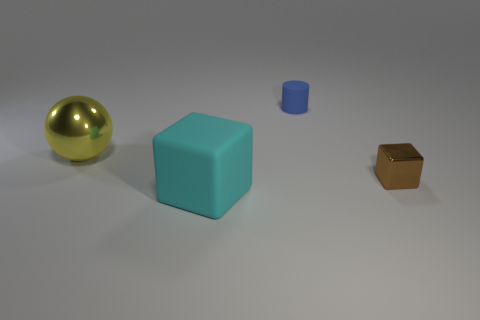Add 3 big rubber objects. How many objects exist? 7 Subtract all blue matte things. Subtract all balls. How many objects are left? 2 Add 1 cyan matte objects. How many cyan matte objects are left? 2 Add 3 blue things. How many blue things exist? 4 Subtract 0 purple cylinders. How many objects are left? 4 